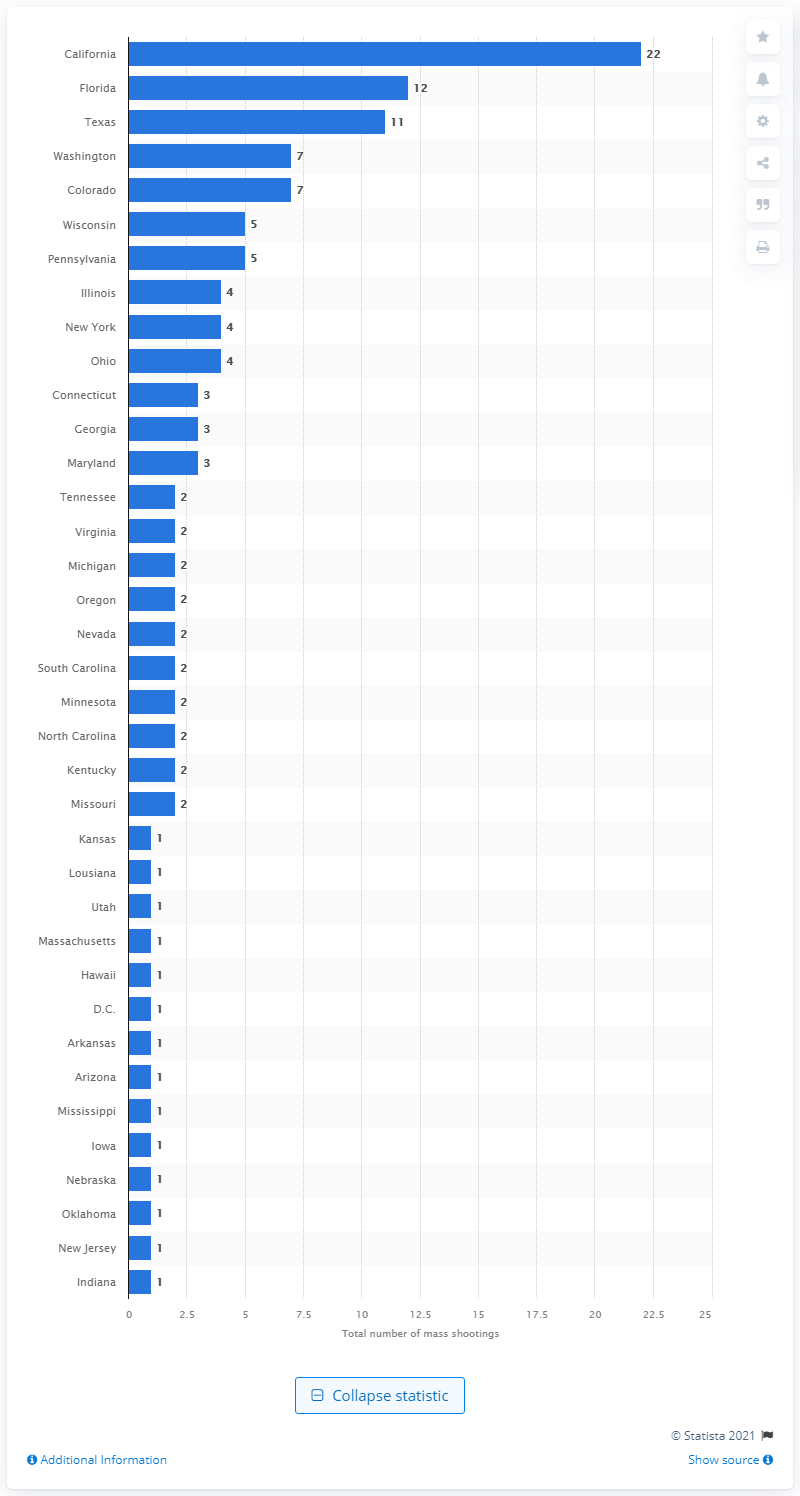Mention a couple of crucial points in this snapshot. In California, there have been 22 mass shootings since 1982. 